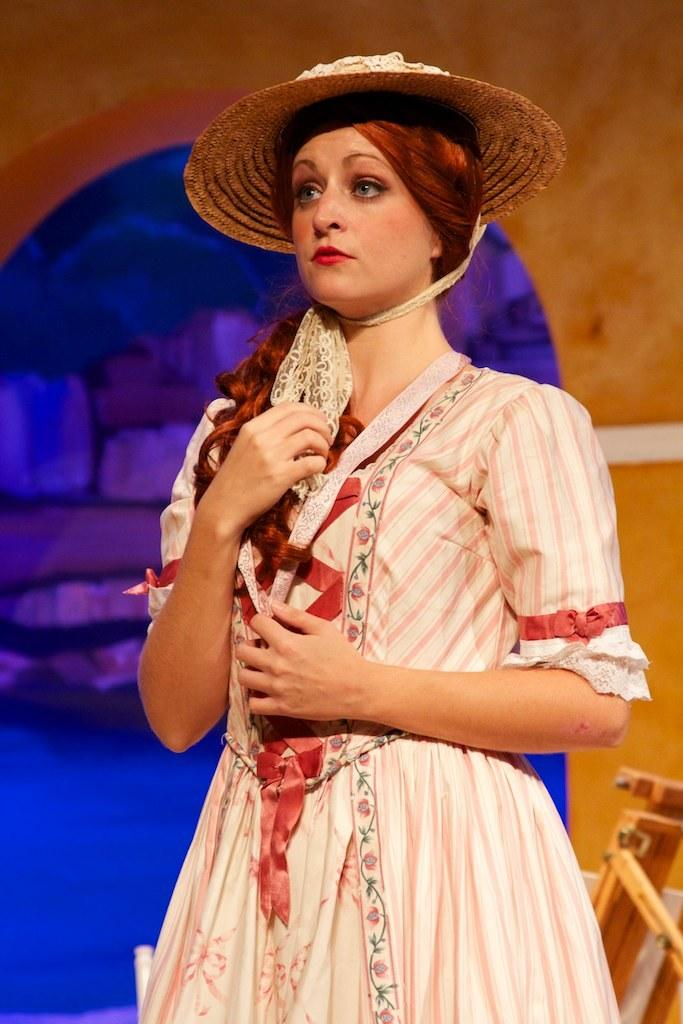Who is the main subject in the image? There is a woman in the image. What is the woman doing in the image? The woman is standing. What accessory is the woman wearing in the image? The woman is wearing a hat. Can you describe the background of the image? The background of the image has brown and blue colors. What type of pie is the woman holding in the image? There is no pie present in the image; the woman is not holding anything. 